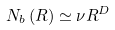<formula> <loc_0><loc_0><loc_500><loc_500>N _ { b } \left ( R \right ) \simeq \nu R ^ { D }</formula> 